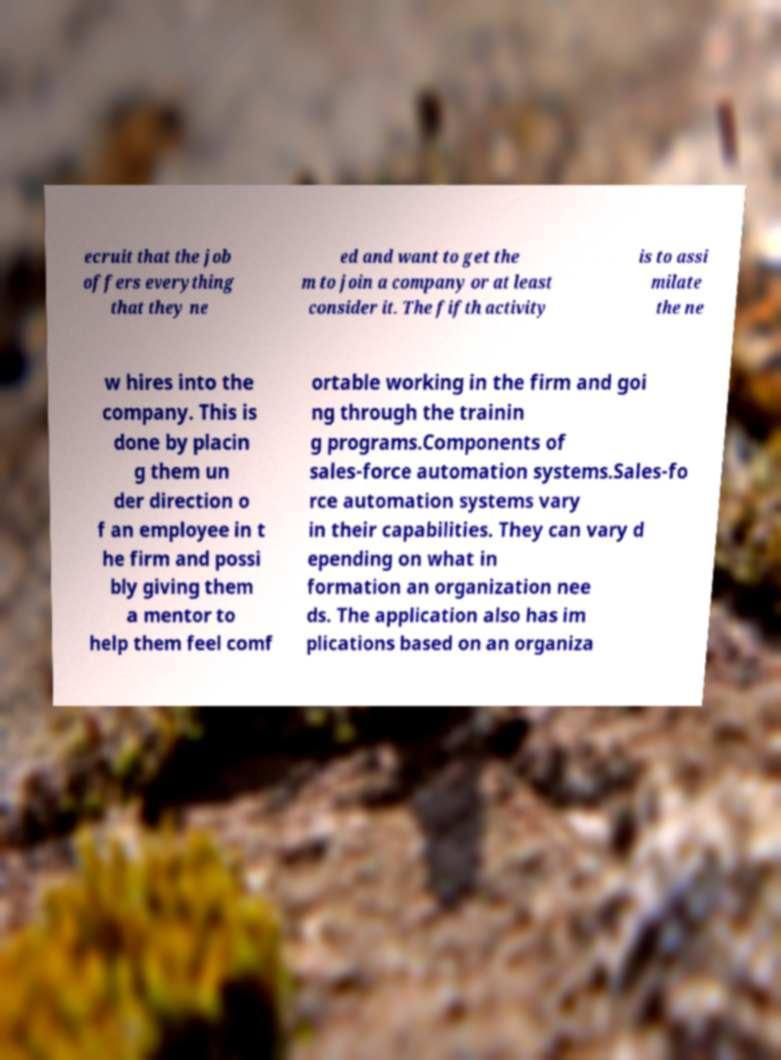What messages or text are displayed in this image? I need them in a readable, typed format. ecruit that the job offers everything that they ne ed and want to get the m to join a company or at least consider it. The fifth activity is to assi milate the ne w hires into the company. This is done by placin g them un der direction o f an employee in t he firm and possi bly giving them a mentor to help them feel comf ortable working in the firm and goi ng through the trainin g programs.Components of sales-force automation systems.Sales-fo rce automation systems vary in their capabilities. They can vary d epending on what in formation an organization nee ds. The application also has im plications based on an organiza 